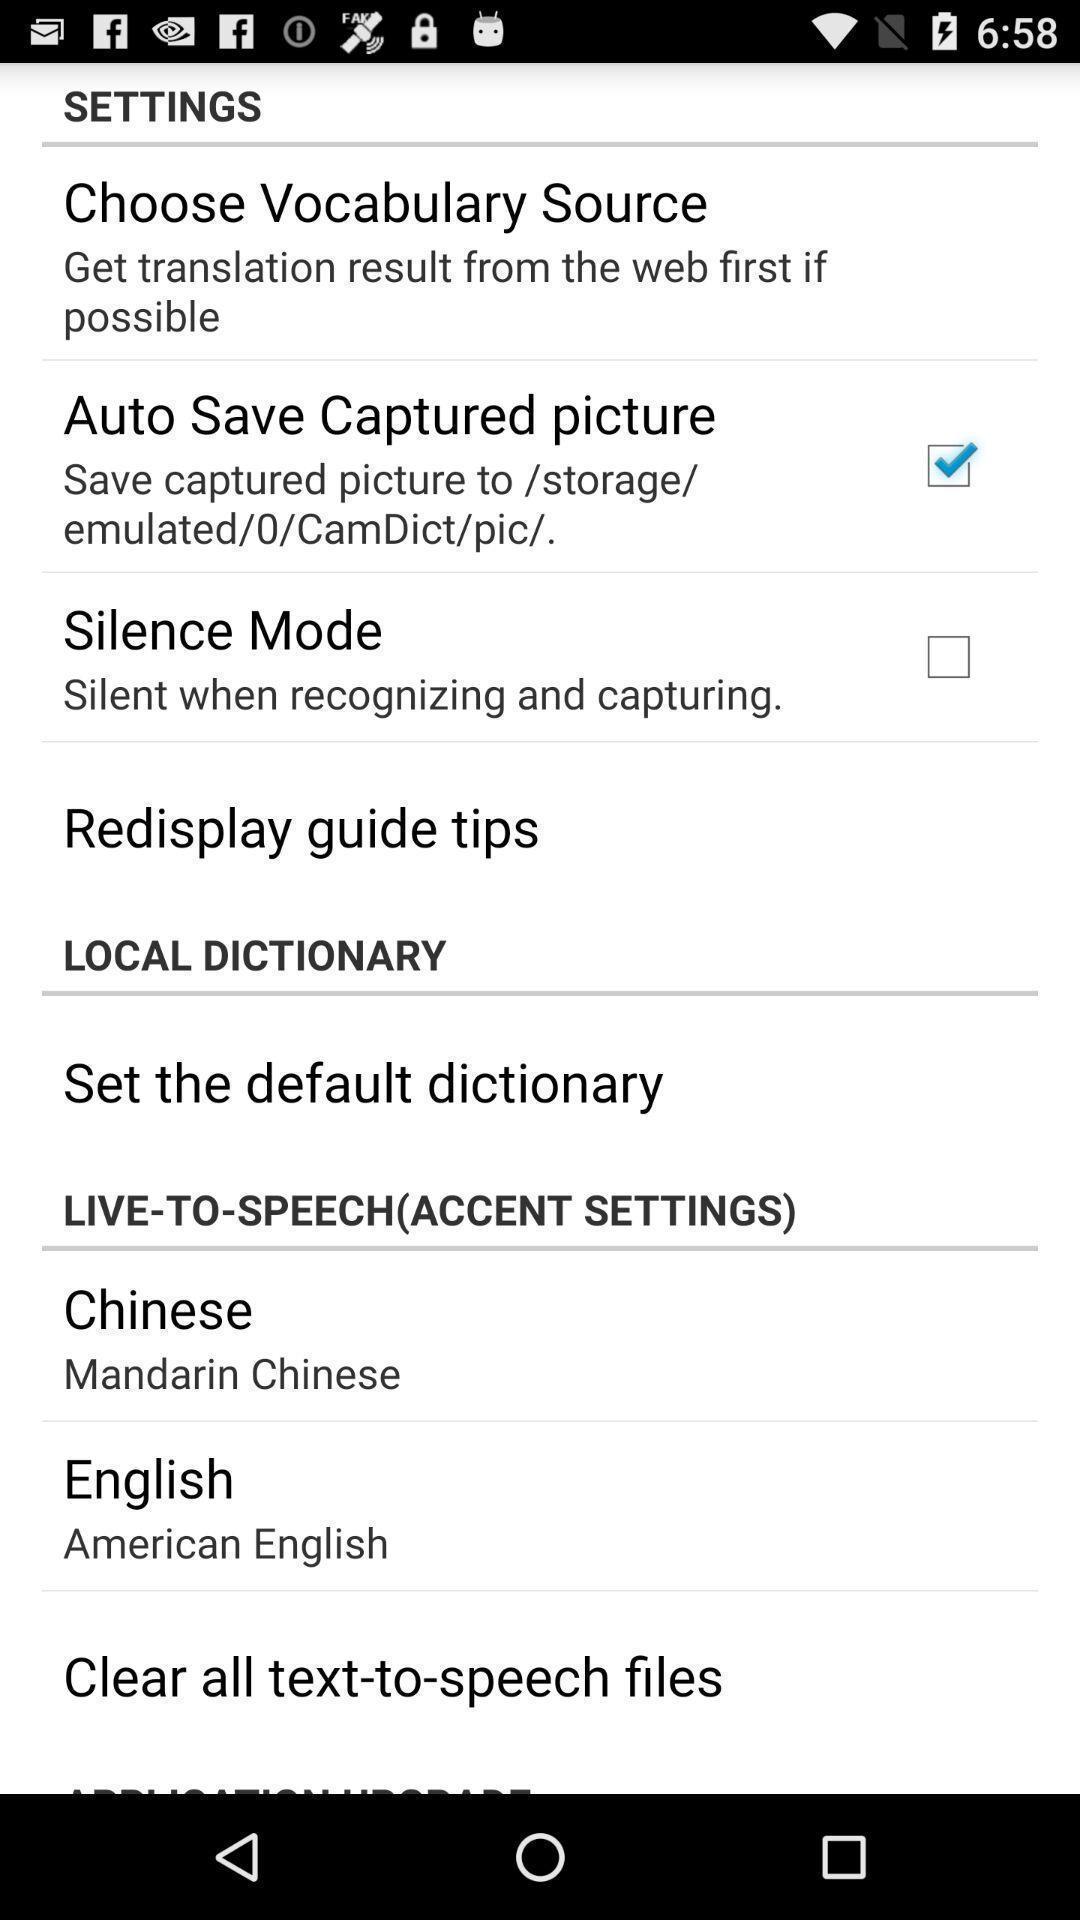Provide a detailed account of this screenshot. Settings page. 